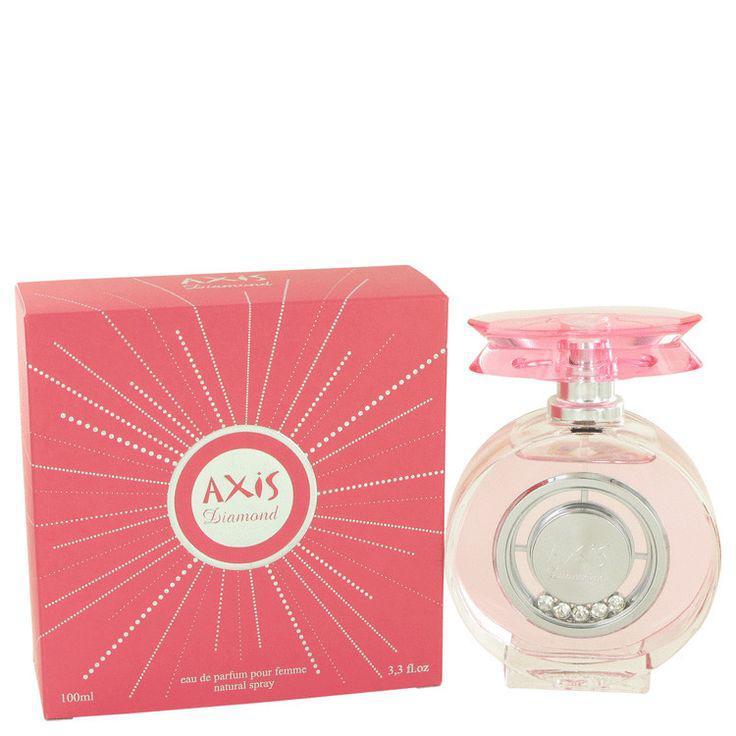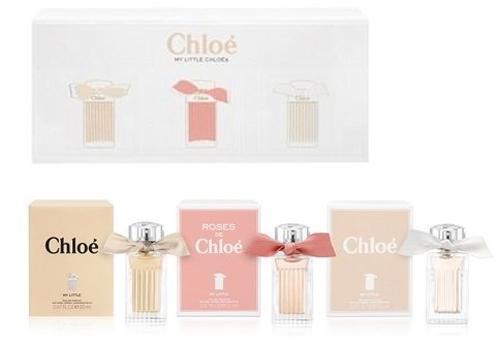The first image is the image on the left, the second image is the image on the right. For the images displayed, is the sentence "There is at least one bottle of perfume being displayed in the center of both images." factually correct? Answer yes or no. Yes. The first image is the image on the left, the second image is the image on the right. Evaluate the accuracy of this statement regarding the images: "In at least one image there are at least two bottle of perfume and at least one box". Is it true? Answer yes or no. Yes. 